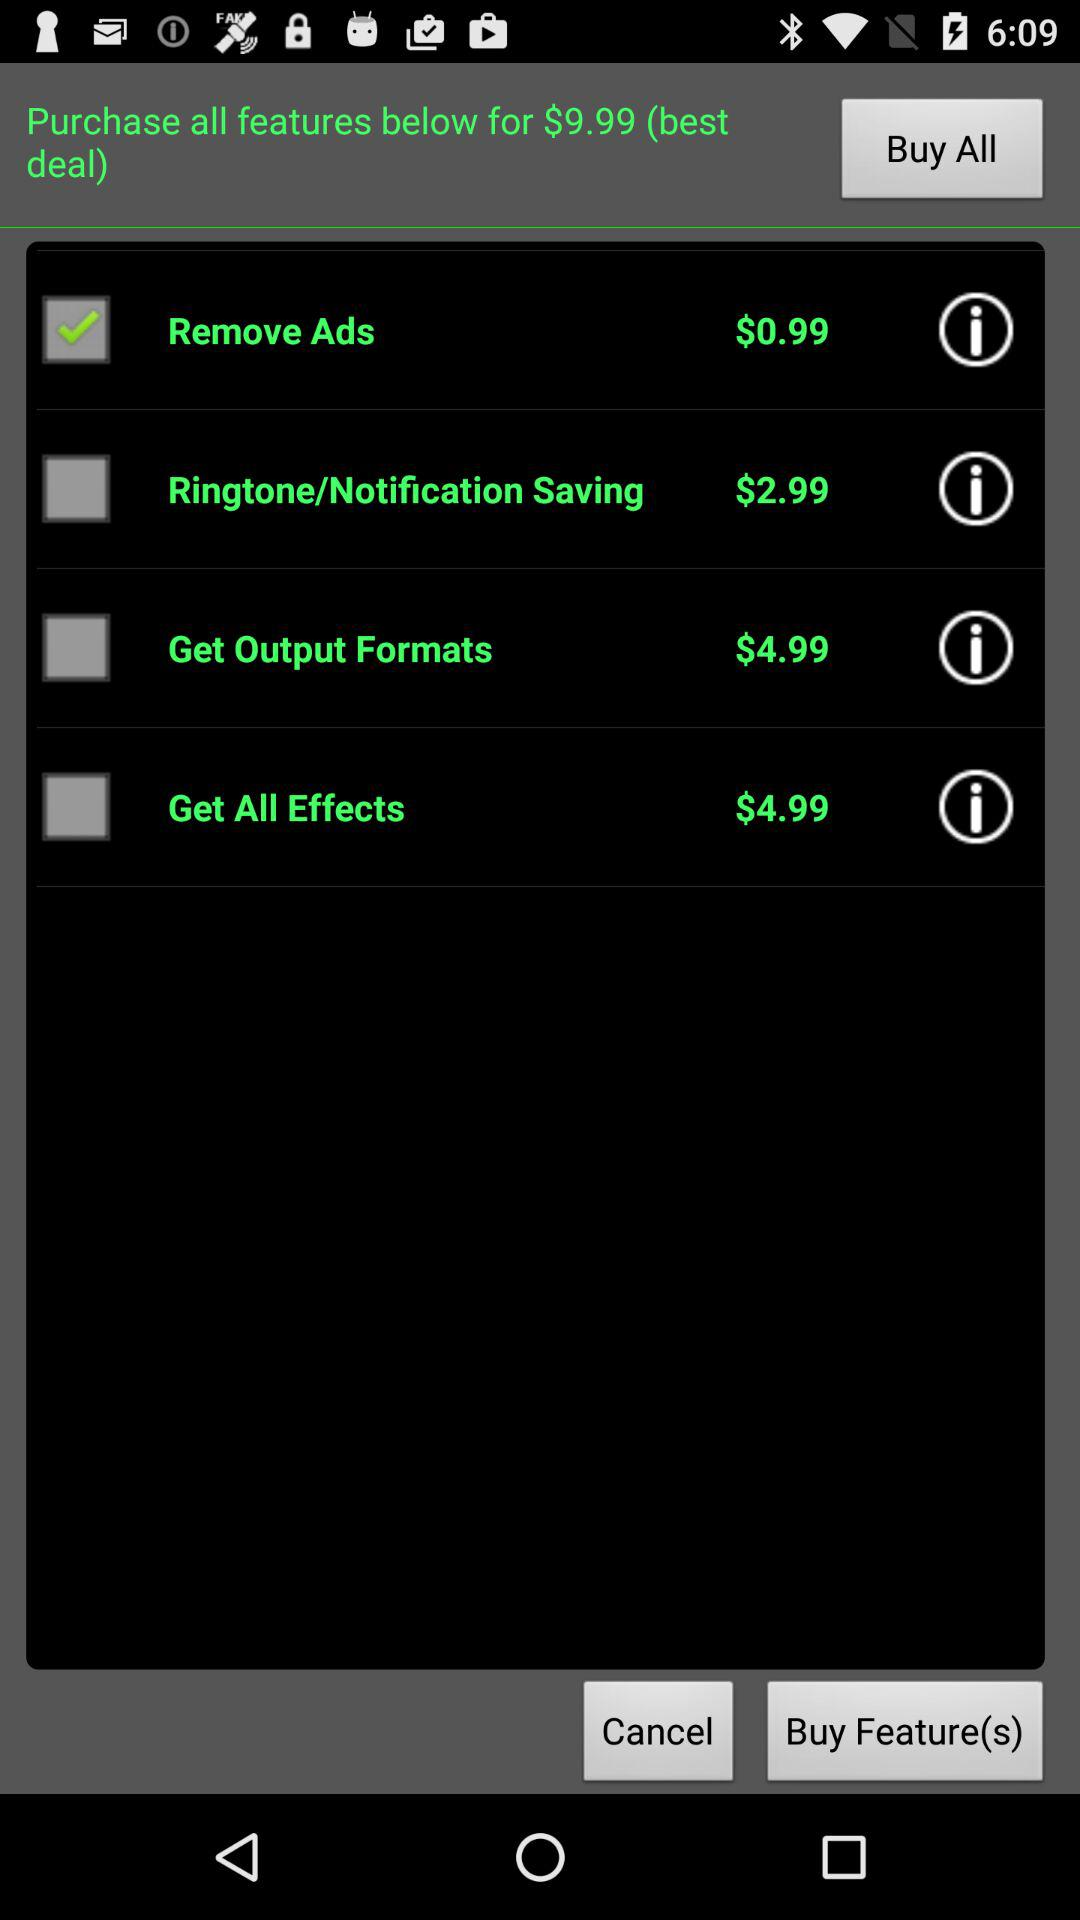What is the purchase price of "Remove Ads"? The price is $0.99. 